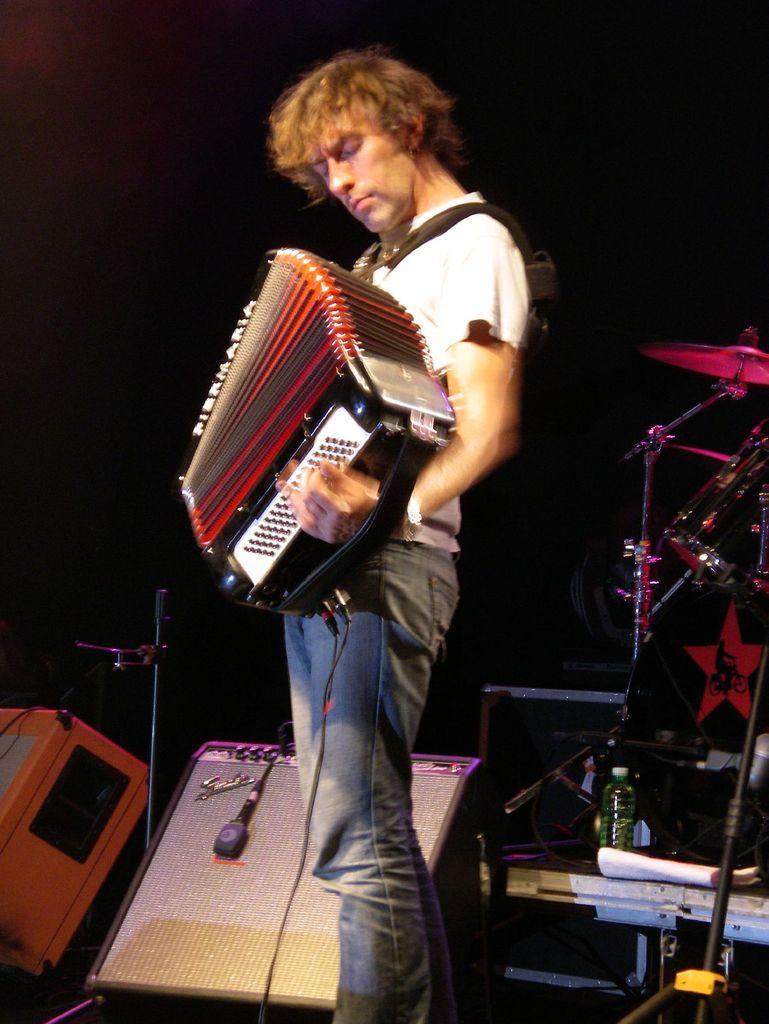In one or two sentences, can you explain what this image depicts? In this image in the center there is one person who is holding some musical instrument and playing. In the background there are some drums, mike, speakers, wires and some other musical instruments. On the right side there are some papers. 